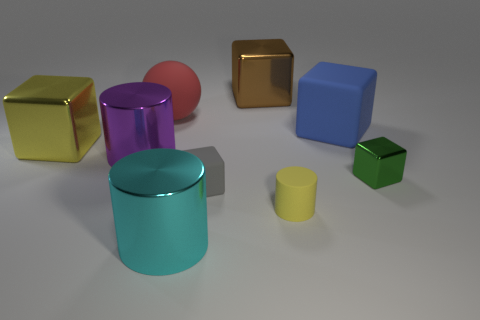Subtract all brown blocks. How many blocks are left? 4 Subtract all large brown metallic blocks. How many blocks are left? 4 Subtract all cyan cubes. Subtract all purple cylinders. How many cubes are left? 5 Add 1 tiny blue metal cylinders. How many objects exist? 10 Subtract all cylinders. How many objects are left? 6 Subtract all small metal blocks. Subtract all red rubber spheres. How many objects are left? 7 Add 1 green shiny blocks. How many green shiny blocks are left? 2 Add 2 large things. How many large things exist? 8 Subtract 0 yellow balls. How many objects are left? 9 